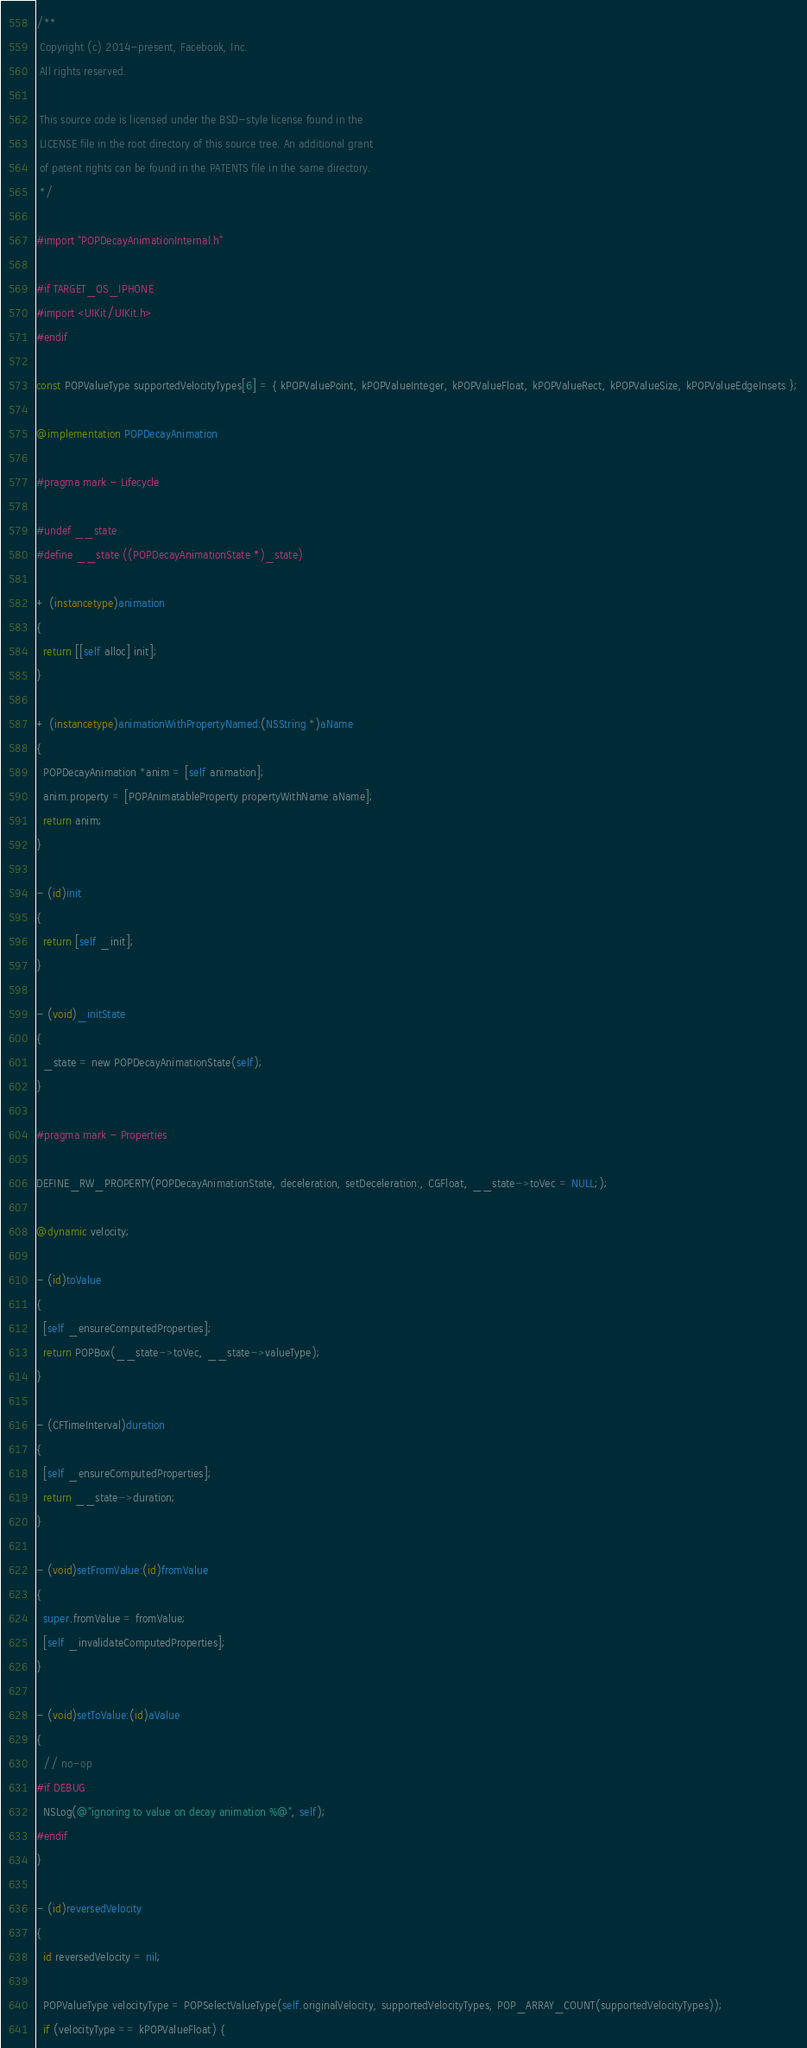Convert code to text. <code><loc_0><loc_0><loc_500><loc_500><_ObjectiveC_>/**
 Copyright (c) 2014-present, Facebook, Inc.
 All rights reserved.

 This source code is licensed under the BSD-style license found in the
 LICENSE file in the root directory of this source tree. An additional grant
 of patent rights can be found in the PATENTS file in the same directory.
 */

#import "POPDecayAnimationInternal.h"

#if TARGET_OS_IPHONE
#import <UIKit/UIKit.h>
#endif

const POPValueType supportedVelocityTypes[6] = { kPOPValuePoint, kPOPValueInteger, kPOPValueFloat, kPOPValueRect, kPOPValueSize, kPOPValueEdgeInsets };

@implementation POPDecayAnimation

#pragma mark - Lifecycle

#undef __state
#define __state ((POPDecayAnimationState *)_state)

+ (instancetype)animation
{
  return [[self alloc] init];
}

+ (instancetype)animationWithPropertyNamed:(NSString *)aName
{
  POPDecayAnimation *anim = [self animation];
  anim.property = [POPAnimatableProperty propertyWithName:aName];
  return anim;
}

- (id)init
{
  return [self _init];
}

- (void)_initState
{
  _state = new POPDecayAnimationState(self);
}

#pragma mark - Properties

DEFINE_RW_PROPERTY(POPDecayAnimationState, deceleration, setDeceleration:, CGFloat, __state->toVec = NULL;);

@dynamic velocity;

- (id)toValue
{
  [self _ensureComputedProperties];
  return POPBox(__state->toVec, __state->valueType);
}

- (CFTimeInterval)duration
{
  [self _ensureComputedProperties];
  return __state->duration;
}

- (void)setFromValue:(id)fromValue
{
  super.fromValue = fromValue;
  [self _invalidateComputedProperties];
}

- (void)setToValue:(id)aValue
{
  // no-op
#if DEBUG
  NSLog(@"ignoring to value on decay animation %@", self);
#endif
}

- (id)reversedVelocity
{
  id reversedVelocity = nil;

  POPValueType velocityType = POPSelectValueType(self.originalVelocity, supportedVelocityTypes, POP_ARRAY_COUNT(supportedVelocityTypes));
  if (velocityType == kPOPValueFloat) {</code> 